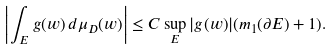<formula> <loc_0><loc_0><loc_500><loc_500>\left | \int _ { E } g ( w ) \, d \mu _ { D } ( w ) \right | \leq C \sup _ { E } | g ( w ) | ( m _ { 1 } ( \partial E ) + 1 ) .</formula> 